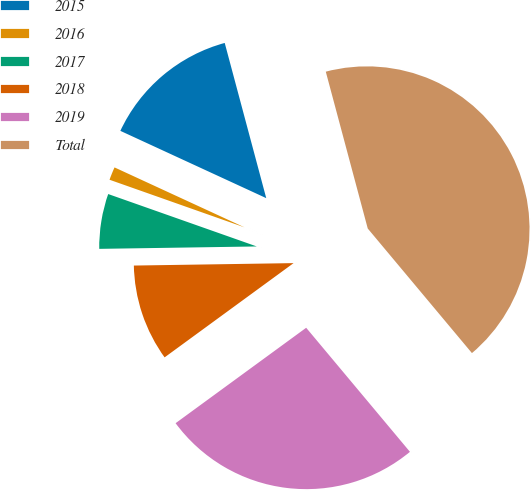<chart> <loc_0><loc_0><loc_500><loc_500><pie_chart><fcel>2015<fcel>2016<fcel>2017<fcel>2018<fcel>2019<fcel>Total<nl><fcel>13.96%<fcel>1.48%<fcel>5.64%<fcel>9.8%<fcel>26.04%<fcel>43.07%<nl></chart> 